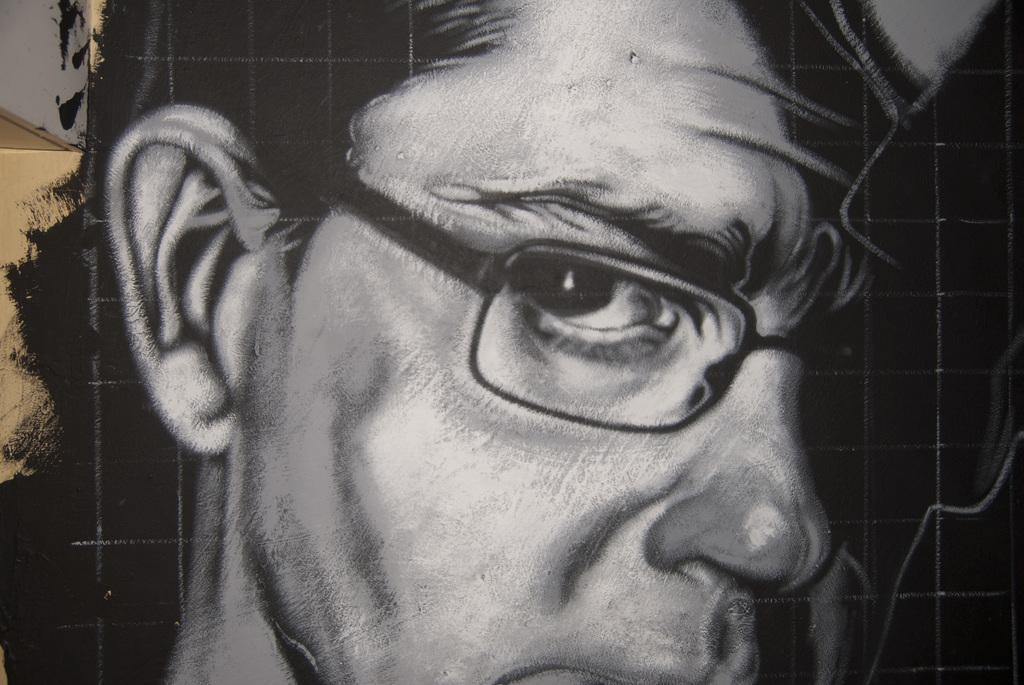What is the main subject of the image? The main subject of the image is a person's painting. Can you describe the person in the painting? The person in the painting is wearing spectacles. What type of cherry is being used as a prop in the painting? There is no cherry present in the painting or the image. What scene is being depicted in the painting? The provided facts do not give enough information to determine the scene being depicted in the painting. 